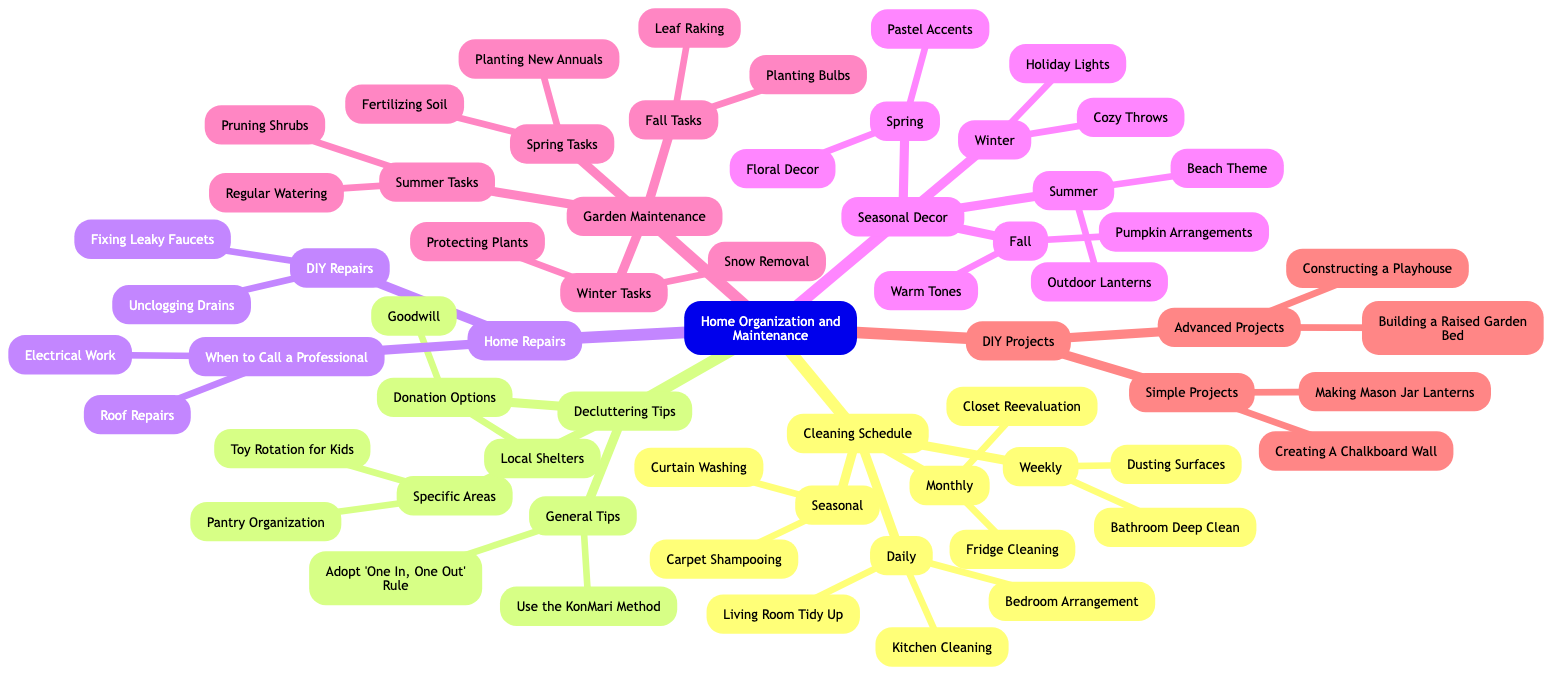What are the two tasks listed under 'Daily' in the Cleaning Schedule? To find the tasks under 'Daily', I locate the "Cleaning Schedule" branch, then look for the 'Daily' node, which lists the tasks: "Living Room Tidy Up" and "Kitchen Cleaning".
Answer: Living Room Tidy Up, Kitchen Cleaning How many categories are under 'Decluttering Tips'? I check the 'Decluttering Tips' node and count the sub-nodes listed under it, which are "General Tips", "Specific Areas", and "Donation Options". There are three categories.
Answer: 3 What is the first task listed under 'Fall Tasks' in Garden Maintenance? I look for the "Garden Maintenance" branch and find the 'Fall Tasks' node. The first task listed there is "Leaf Raking".
Answer: Leaf Raking What color theme is suggested for Spring decor? I navigate to the "Seasonal Decor" branch and find the 'Spring' section. The suggested color theme for Spring decor is "Floral Decor."
Answer: Floral Decor Which two DIY Repairs are suggested in the Home Repairs section? By checking the "Home Repairs" branch, I look for the "DIY Repairs" node and see it includes "Fixing Leaky Faucets" and "Unclogging Drains."
Answer: Fixing Leaky Faucets, Unclogging Drains What is the frequency of "Fridge Cleaning" in the Cleaning Schedule? I find "Fridge Cleaning" in the "Monthly" sub-node of the "Cleaning Schedule", indicating that it is a task that occurs monthly.
Answer: Monthly How many seasonal categories are present in the Seasonal Decor section? I check the "Seasonal Decor" section, where there are four sub-nodes: "Spring", "Summer", "Fall", and "Winter". That gives a total of four seasonal categories.
Answer: 4 What type of project is "Building a Raised Garden Bed" classified under? I find "Building a Raised Garden Bed" under the "Advanced Projects" section in the "DIY Projects" category, indicating that it is classified as an advanced project.
Answer: Advanced Projects What guideline does the 'General Tips' section under Decluttering Tips mention for managing incoming items? In the "Decluttering Tips" section, under "General Tips", the included guideline is "Adopt 'One In, One Out' Rule," which suggests managing incoming items effectively.
Answer: Adopt 'One In, One Out' Rule 